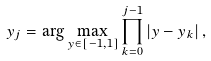Convert formula to latex. <formula><loc_0><loc_0><loc_500><loc_500>y _ { j } = \arg \max _ { y \in \left [ - 1 , 1 \right ] } \prod _ { k = 0 } ^ { j - 1 } \left | y - y _ { k } \right | ,</formula> 